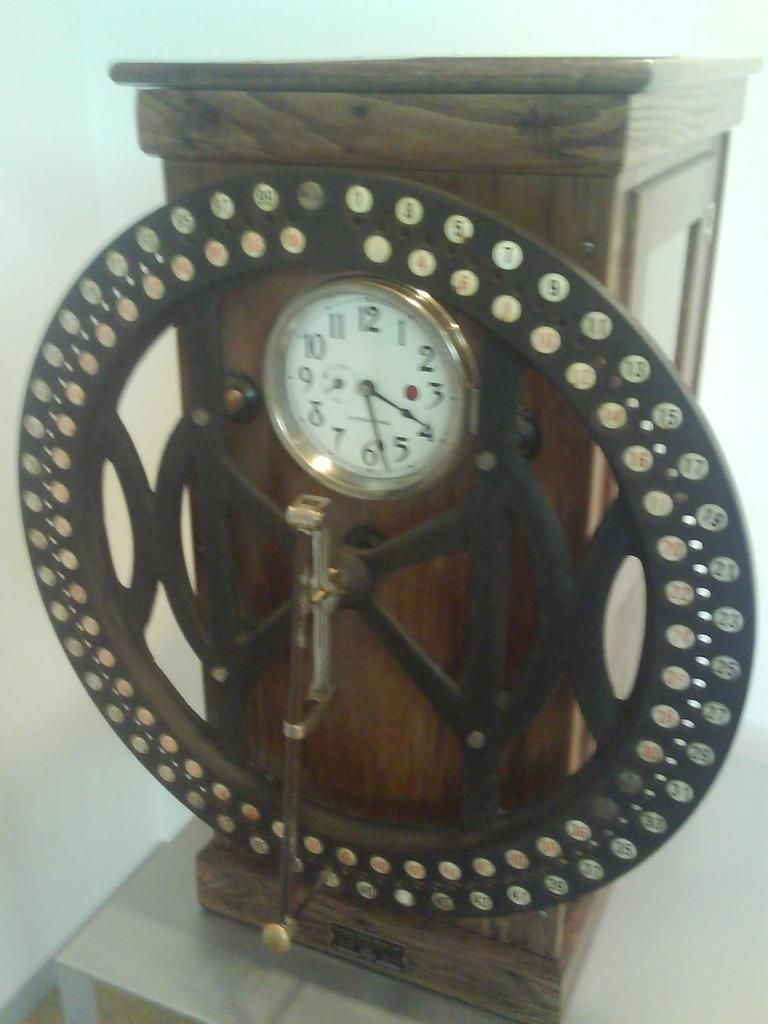<image>
Summarize the visual content of the image. A white faced clock showing the time as 4:29 is set in an ornate metal piece attached to a wooden base. 